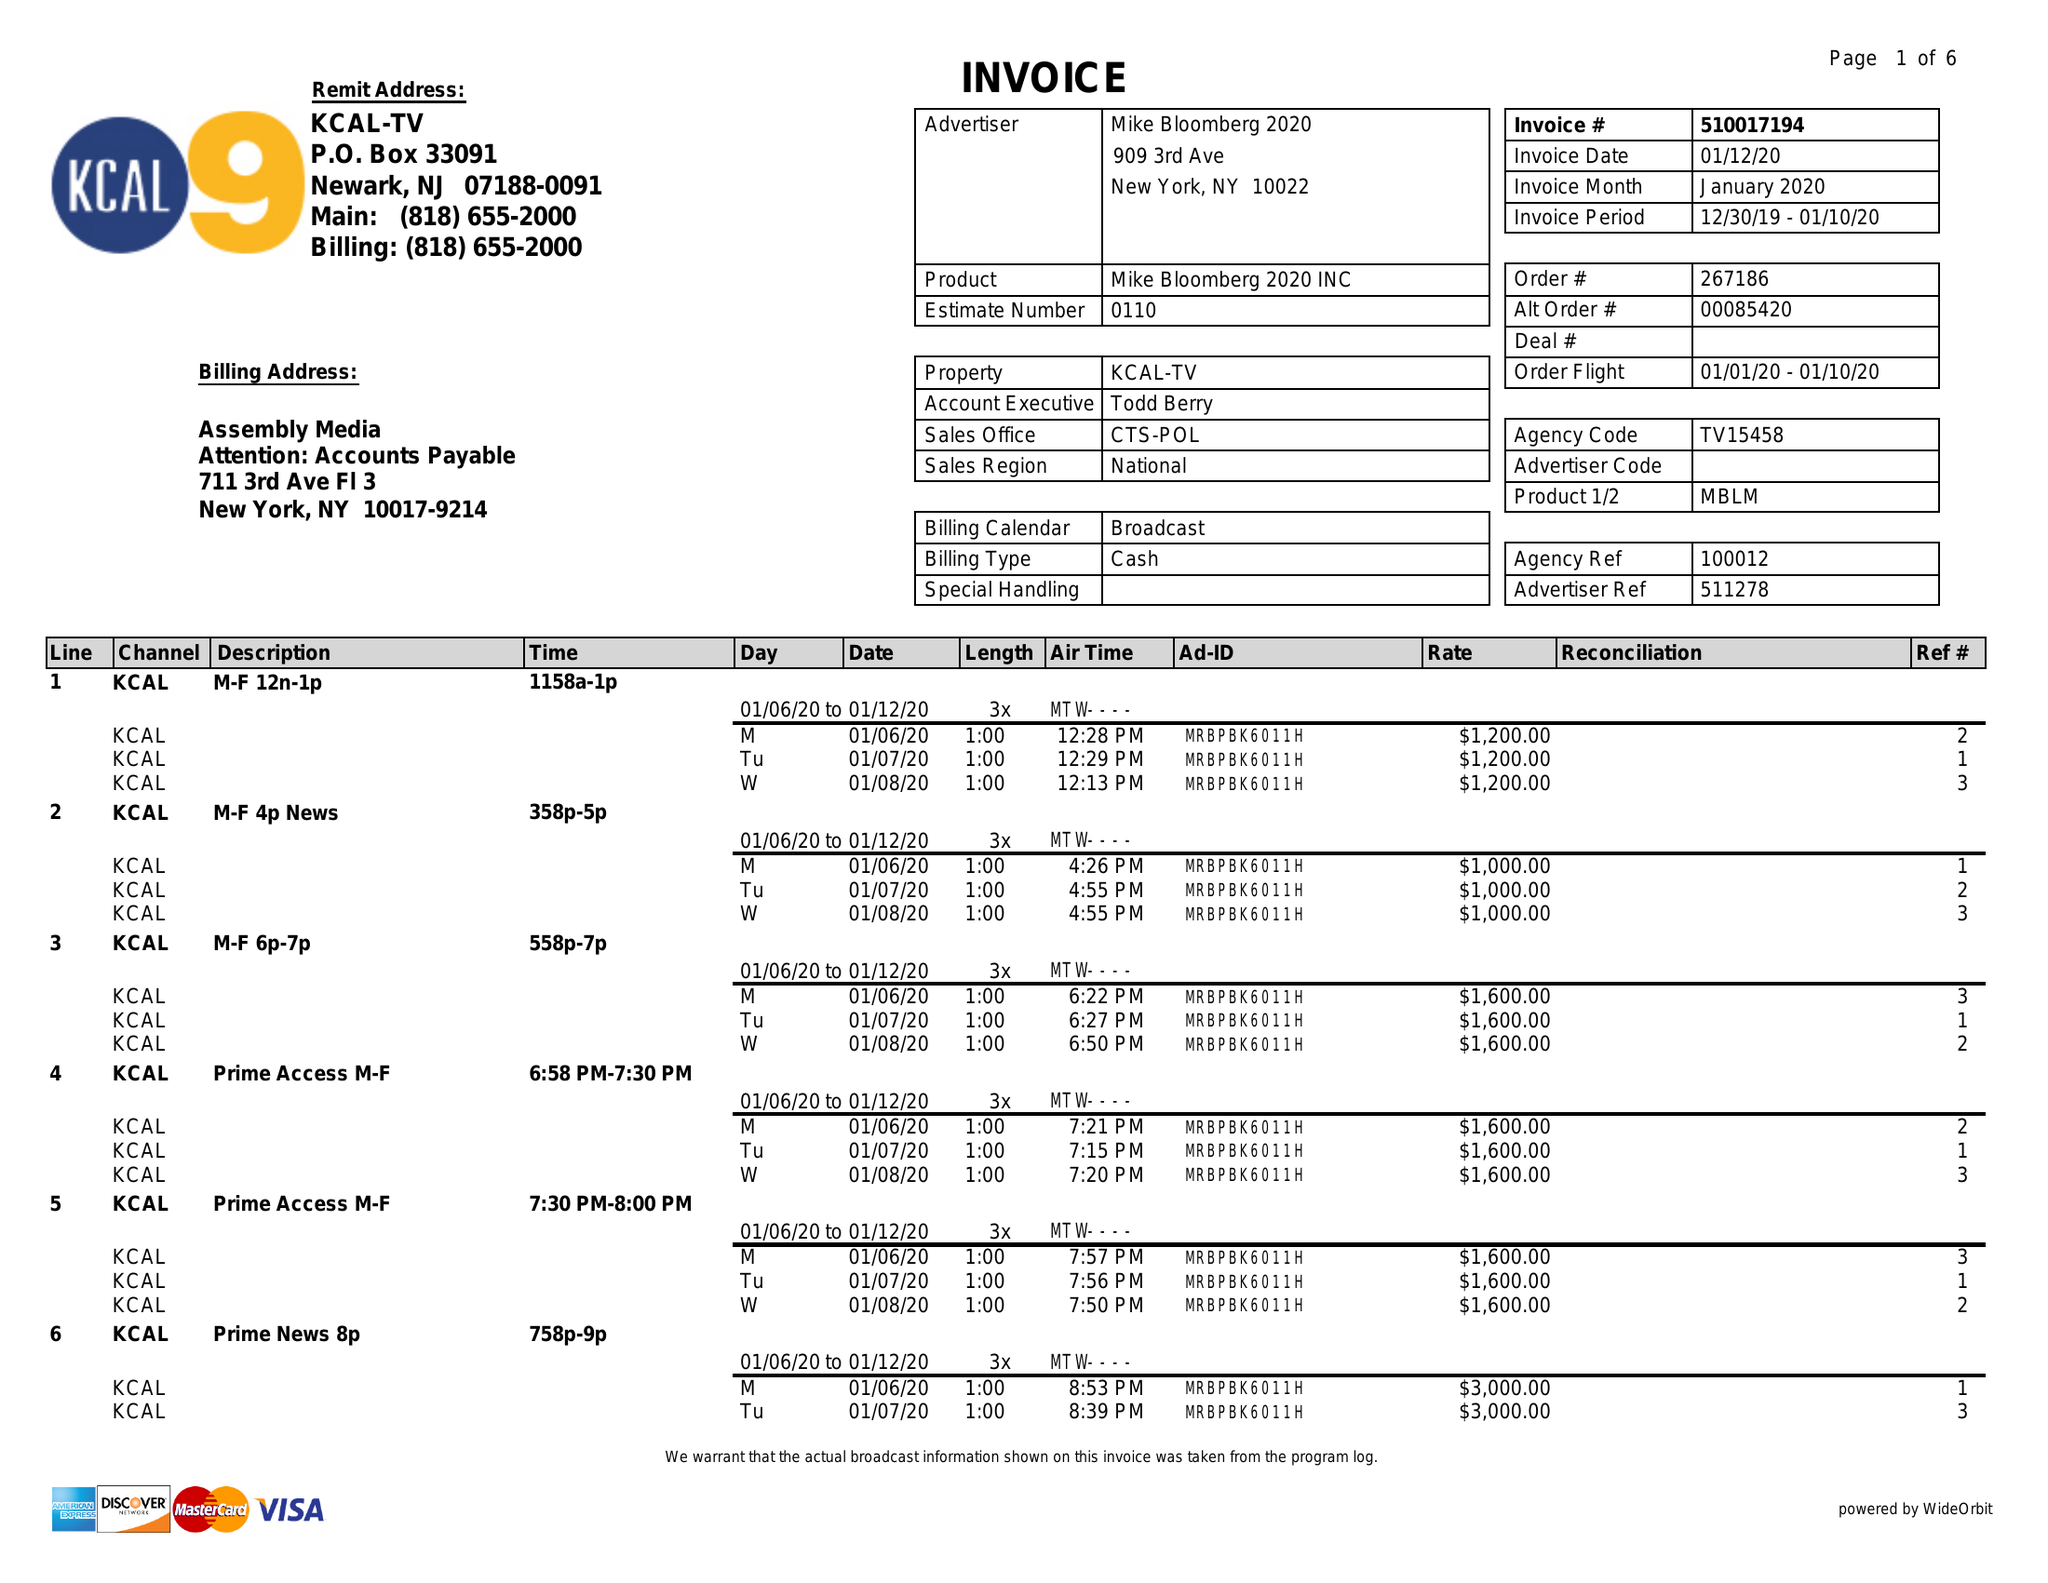What is the value for the flight_from?
Answer the question using a single word or phrase. 12/30/19 